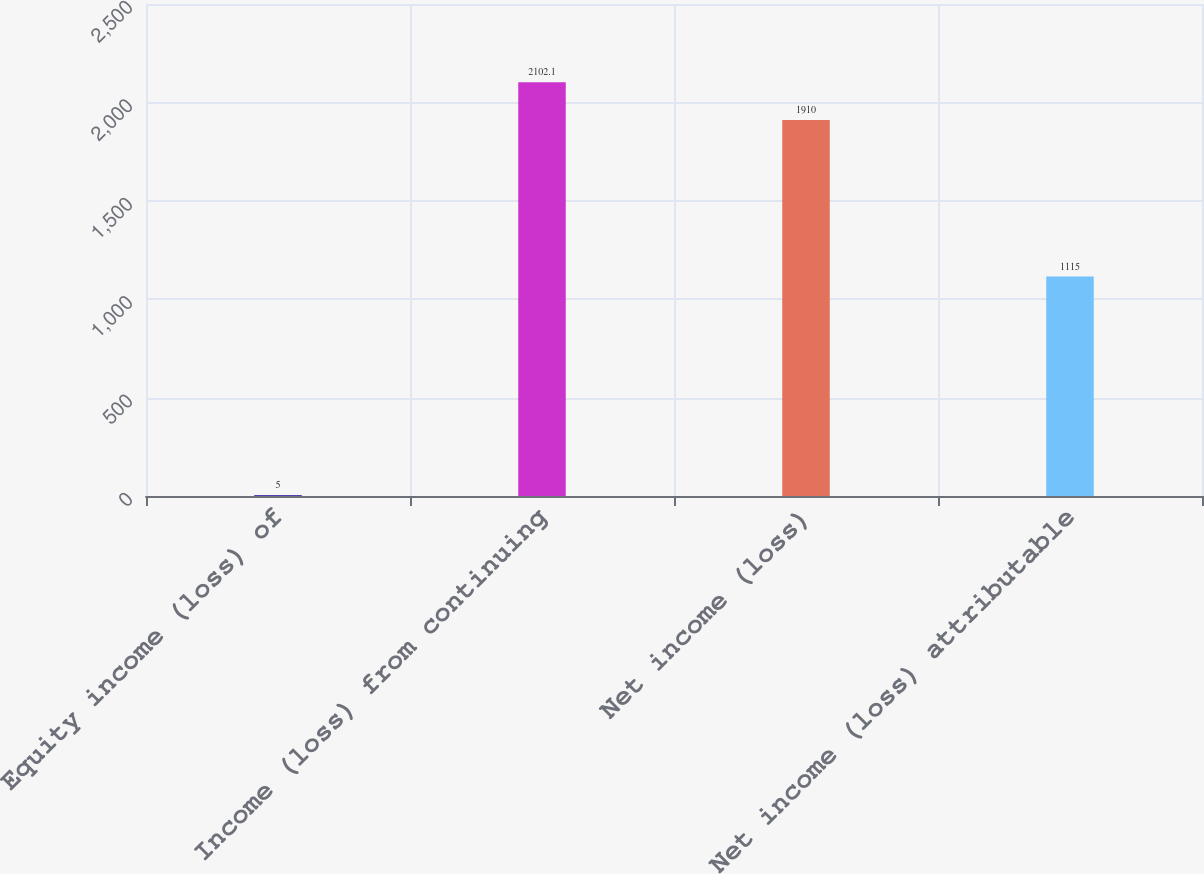Convert chart to OTSL. <chart><loc_0><loc_0><loc_500><loc_500><bar_chart><fcel>Equity income (loss) of<fcel>Income (loss) from continuing<fcel>Net income (loss)<fcel>Net income (loss) attributable<nl><fcel>5<fcel>2102.1<fcel>1910<fcel>1115<nl></chart> 